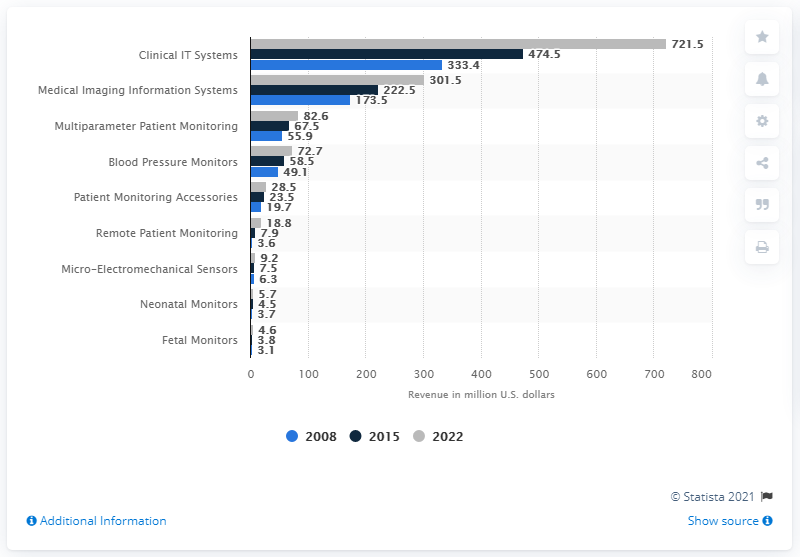Indicate a few pertinent items in this graphic. The projected revenue from clinical IT systems by 2022 is expected to be approximately 721.5. The total value of the healthcare IT market in Canada in 2015 was 474.5 million dollars. 